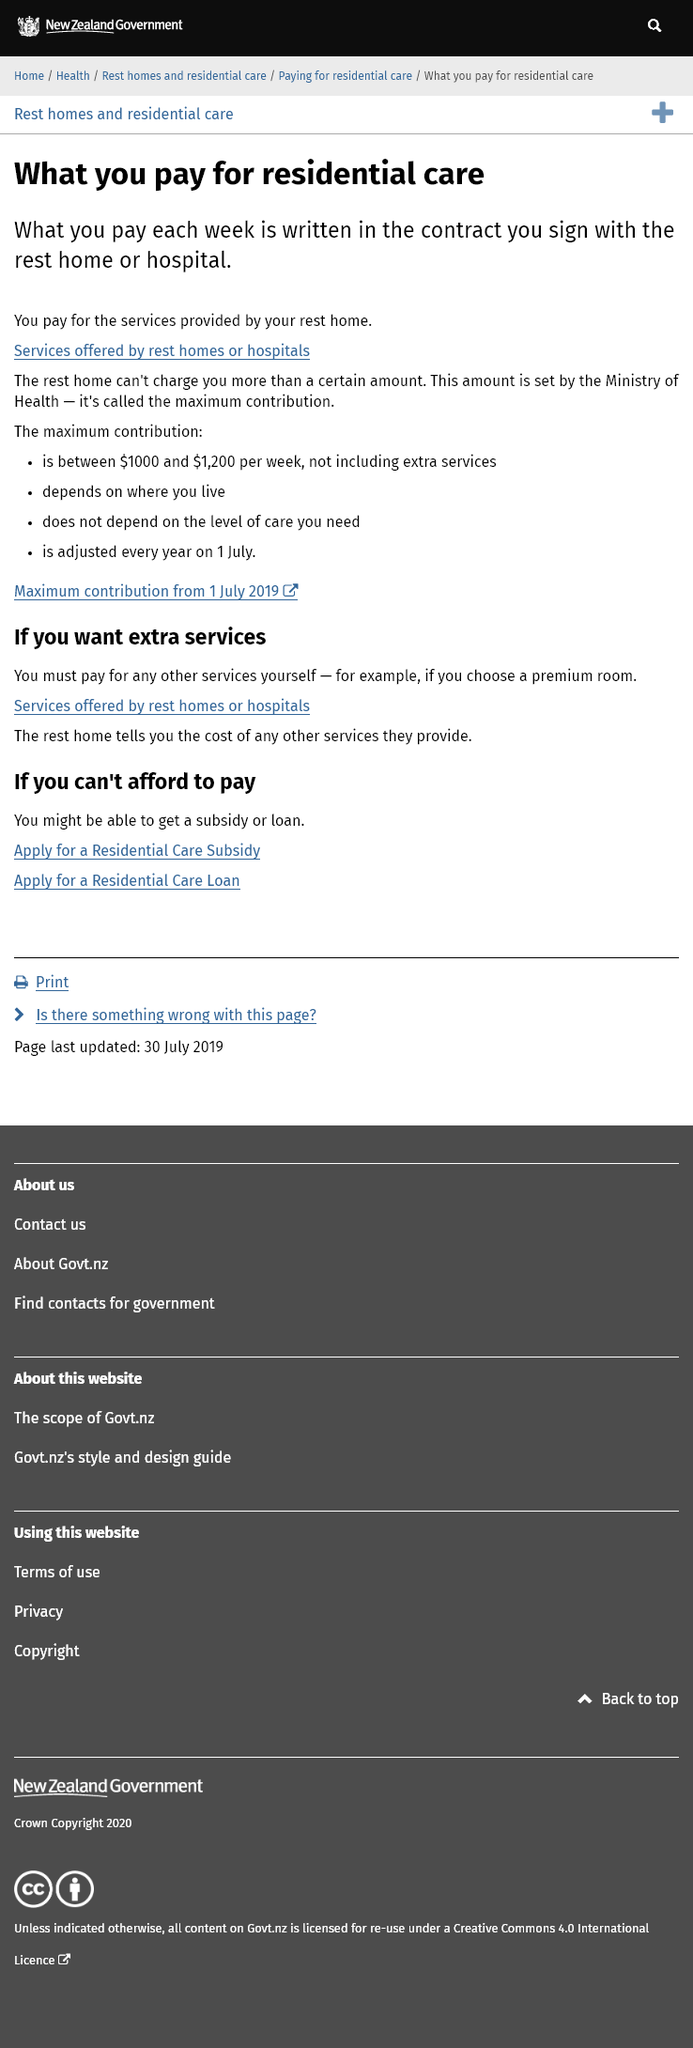Point out several critical features in this image. I, [your name], am able to make a maximum contribution of between $1000 and $1200 per week for residential care, excluding any additional services. It is necessary for the user to pay for a premium room if they choose to do so. The maximum contribution amount is determined by the Ministry of Health. 